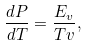<formula> <loc_0><loc_0><loc_500><loc_500>\frac { d P } { d T } = \frac { { E _ { v } } } { T v } ,</formula> 